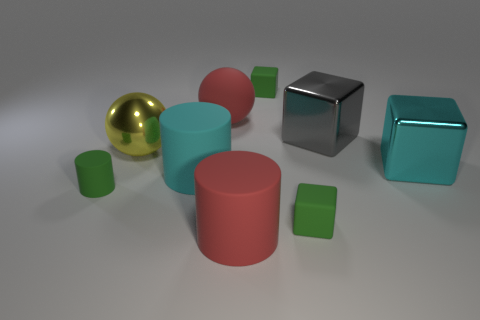Subtract all red matte cylinders. How many cylinders are left? 2 Add 1 green matte things. How many objects exist? 10 Subtract all green cylinders. How many cylinders are left? 2 Add 4 small blue rubber blocks. How many small blue rubber blocks exist? 4 Subtract 0 blue blocks. How many objects are left? 9 Subtract all cylinders. How many objects are left? 6 Subtract 1 balls. How many balls are left? 1 Subtract all green spheres. Subtract all green cubes. How many spheres are left? 2 Subtract all red cylinders. How many green cubes are left? 2 Subtract all red cylinders. Subtract all big metal cubes. How many objects are left? 6 